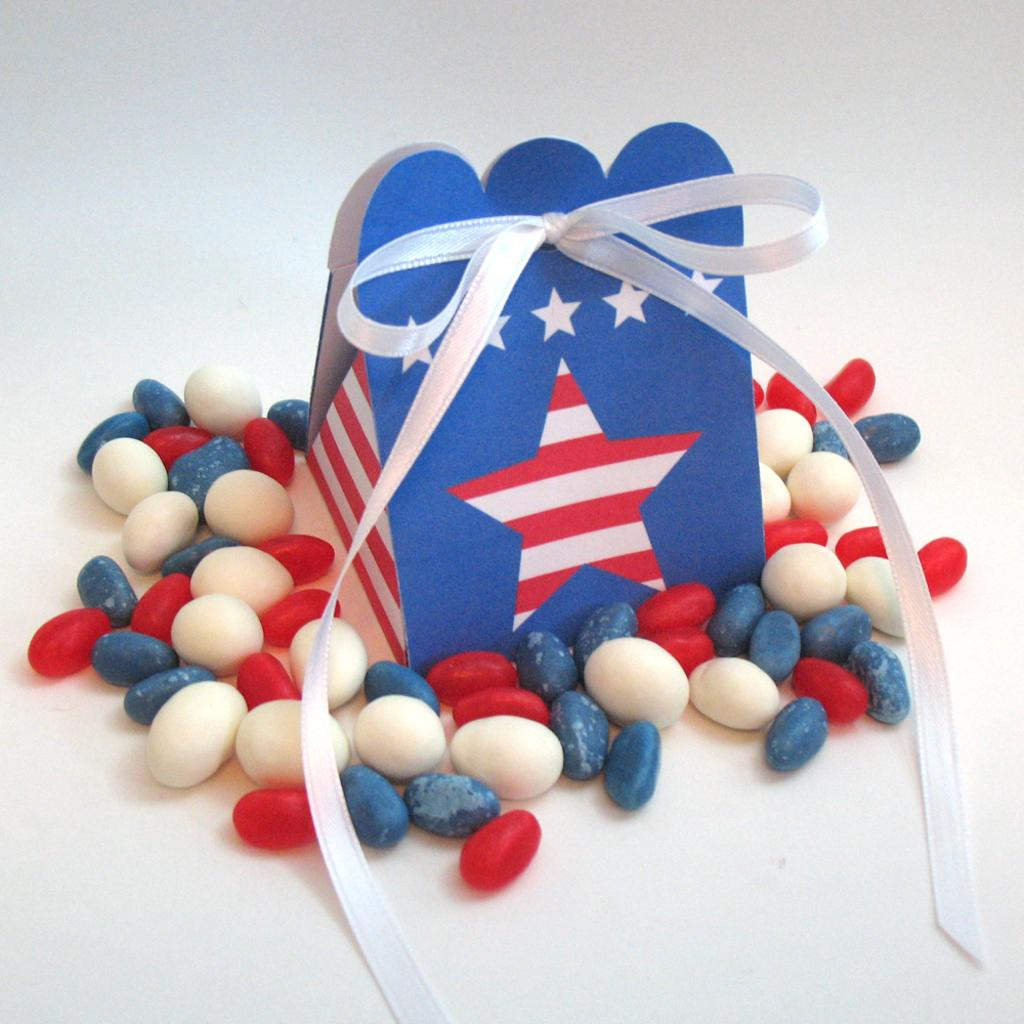What type of material is visible in the image? There are marble stones in the image. What is the color of the surface on which the object is placed? The object is on a white color surface in the image. What is attached to the object in the image? The object has a white color ribbon attached to it. Can you tell me how many clovers are growing among the marble stones in the image? There are no clovers present in the image; it features marble stones and an object with a ribbon. What time is displayed on the clock in the image? There is no clock present in the image; it features marble stones and an object with a ribbon. 